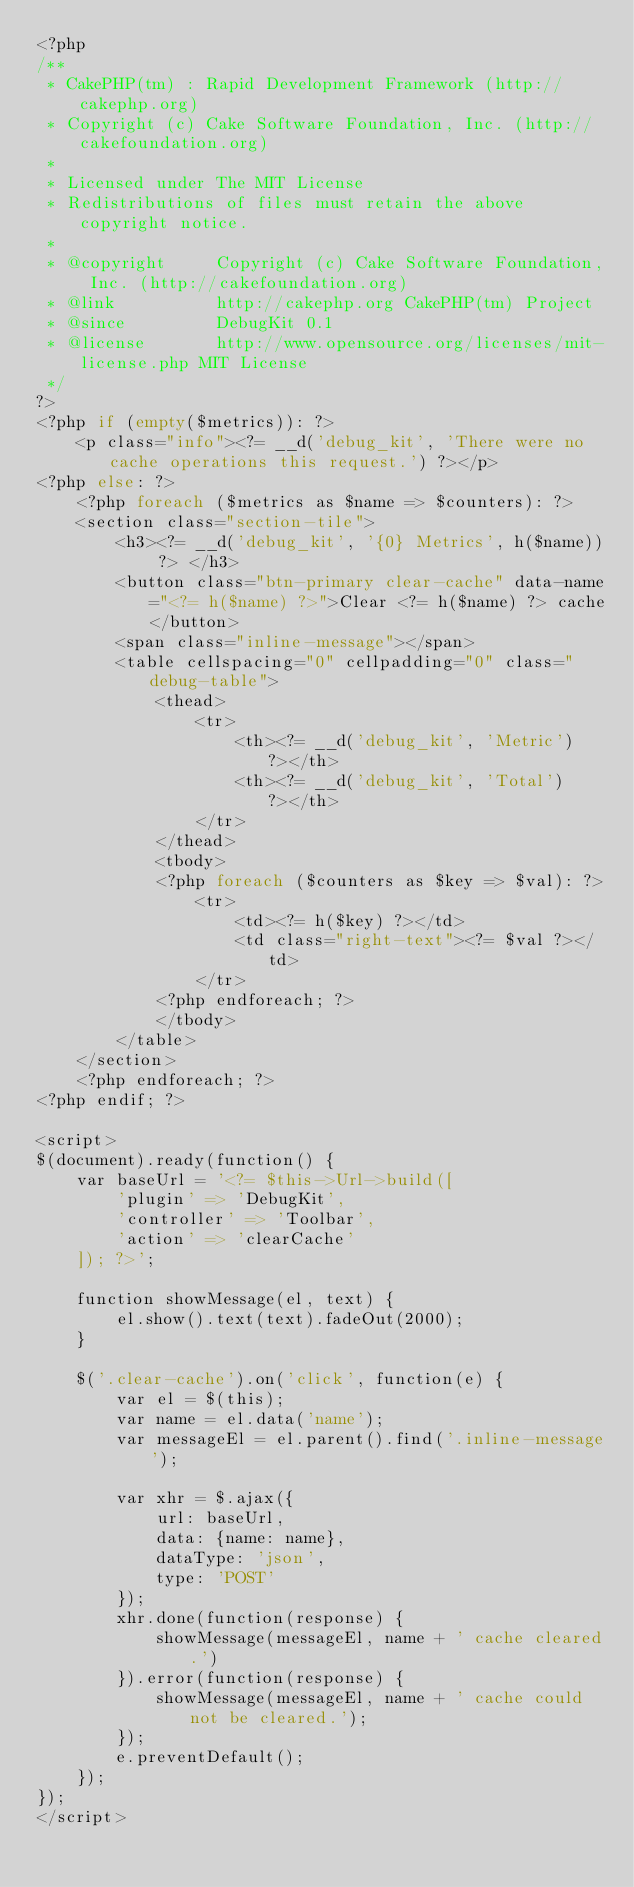<code> <loc_0><loc_0><loc_500><loc_500><_PHP_><?php
/**
 * CakePHP(tm) : Rapid Development Framework (http://cakephp.org)
 * Copyright (c) Cake Software Foundation, Inc. (http://cakefoundation.org)
 *
 * Licensed under The MIT License
 * Redistributions of files must retain the above copyright notice.
 *
 * @copyright     Copyright (c) Cake Software Foundation, Inc. (http://cakefoundation.org)
 * @link          http://cakephp.org CakePHP(tm) Project
 * @since         DebugKit 0.1
 * @license       http://www.opensource.org/licenses/mit-license.php MIT License
 */
?>
<?php if (empty($metrics)): ?>
    <p class="info"><?= __d('debug_kit', 'There were no cache operations this request.') ?></p>
<?php else: ?>
    <?php foreach ($metrics as $name => $counters): ?>
    <section class="section-tile">
        <h3><?= __d('debug_kit', '{0} Metrics', h($name)) ?> </h3>
        <button class="btn-primary clear-cache" data-name="<?= h($name) ?>">Clear <?= h($name) ?> cache</button>
        <span class="inline-message"></span>
        <table cellspacing="0" cellpadding="0" class="debug-table">
            <thead>
                <tr>
                    <th><?= __d('debug_kit', 'Metric') ?></th>
                    <th><?= __d('debug_kit', 'Total') ?></th>
                </tr>
            </thead>
            <tbody>
            <?php foreach ($counters as $key => $val): ?>
                <tr>
                    <td><?= h($key) ?></td>
                    <td class="right-text"><?= $val ?></td>
                </tr>
            <?php endforeach; ?>
            </tbody>
        </table>
    </section>
    <?php endforeach; ?>
<?php endif; ?>

<script>
$(document).ready(function() {
    var baseUrl = '<?= $this->Url->build([
        'plugin' => 'DebugKit',
        'controller' => 'Toolbar',
        'action' => 'clearCache'
    ]); ?>';

    function showMessage(el, text) {
        el.show().text(text).fadeOut(2000);
    }

    $('.clear-cache').on('click', function(e) {
        var el = $(this);
        var name = el.data('name');
        var messageEl = el.parent().find('.inline-message');

        var xhr = $.ajax({
            url: baseUrl,
            data: {name: name},
            dataType: 'json',
            type: 'POST'
        });
        xhr.done(function(response) {
            showMessage(messageEl, name + ' cache cleared.')
        }).error(function(response) {
            showMessage(messageEl, name + ' cache could not be cleared.');
        });
        e.preventDefault();
    });
});
</script>
</code> 